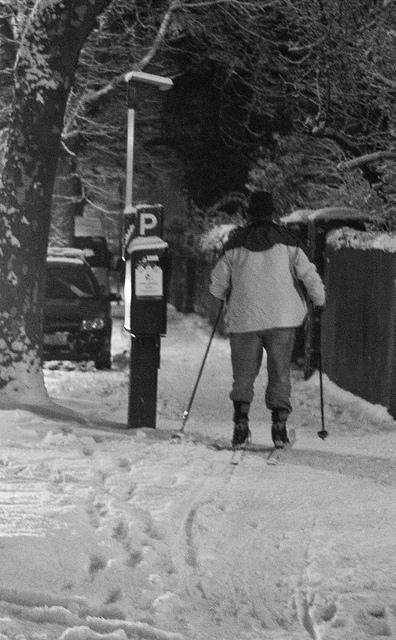What type of area is this?
Choose the correct response, then elucidate: 'Answer: answer
Rationale: rationale.'
Options: Mountain, residential, forest, beach. Answer: residential.
Rationale: The yard fences and sidewalks make it look like an area for homes. 